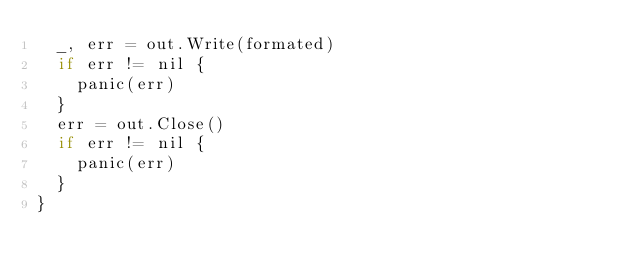Convert code to text. <code><loc_0><loc_0><loc_500><loc_500><_Go_>	_, err = out.Write(formated)
	if err != nil {
		panic(err)
	}
	err = out.Close()
	if err != nil {
		panic(err)
	}
}
</code> 